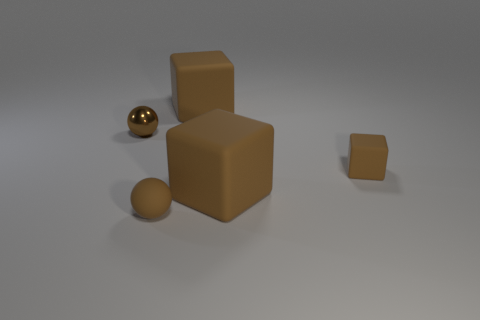Is the color of the small metal ball the same as the tiny object that is right of the brown rubber sphere?
Make the answer very short. Yes. What shape is the tiny object in front of the large cube in front of the brown matte block behind the small shiny thing?
Keep it short and to the point. Sphere. Do the brown thing behind the shiny ball and the brown sphere in front of the shiny thing have the same size?
Your response must be concise. No. What number of small brown things have the same material as the tiny cube?
Make the answer very short. 1. What number of brown balls are behind the small brown thing in front of the tiny brown object that is right of the brown matte sphere?
Ensure brevity in your answer.  1. Is there another small shiny object that has the same shape as the tiny shiny thing?
Keep it short and to the point. No. There is a shiny object that is the same size as the brown rubber sphere; what is its shape?
Provide a short and direct response. Sphere. The tiny sphere that is behind the large matte thing that is to the right of the big brown rubber block behind the tiny brown matte block is made of what material?
Provide a short and direct response. Metal. Does the metal object have the same size as the rubber ball?
Provide a short and direct response. Yes. What is the small cube made of?
Make the answer very short. Rubber. 